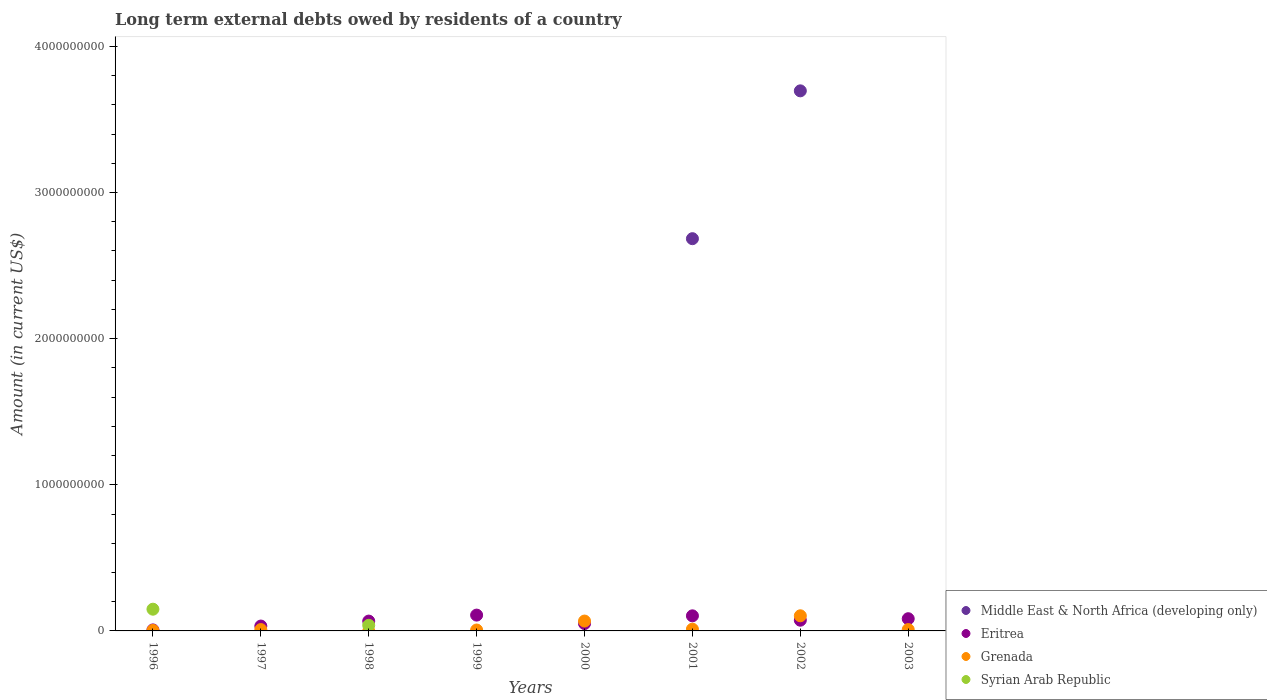Is the number of dotlines equal to the number of legend labels?
Ensure brevity in your answer.  No. What is the amount of long-term external debts owed by residents in Grenada in 1996?
Ensure brevity in your answer.  3.57e+06. Across all years, what is the maximum amount of long-term external debts owed by residents in Grenada?
Ensure brevity in your answer.  1.04e+08. Across all years, what is the minimum amount of long-term external debts owed by residents in Eritrea?
Make the answer very short. 6.93e+06. In which year was the amount of long-term external debts owed by residents in Syrian Arab Republic maximum?
Keep it short and to the point. 1996. What is the total amount of long-term external debts owed by residents in Grenada in the graph?
Your answer should be compact. 2.11e+08. What is the difference between the amount of long-term external debts owed by residents in Eritrea in 1996 and that in 1999?
Offer a terse response. -1.01e+08. What is the difference between the amount of long-term external debts owed by residents in Syrian Arab Republic in 2002 and the amount of long-term external debts owed by residents in Middle East & North Africa (developing only) in 2001?
Make the answer very short. -2.68e+09. What is the average amount of long-term external debts owed by residents in Eritrea per year?
Keep it short and to the point. 6.58e+07. In the year 2002, what is the difference between the amount of long-term external debts owed by residents in Eritrea and amount of long-term external debts owed by residents in Middle East & North Africa (developing only)?
Your answer should be compact. -3.62e+09. What is the ratio of the amount of long-term external debts owed by residents in Eritrea in 1999 to that in 2002?
Offer a very short reply. 1.48. Is the amount of long-term external debts owed by residents in Grenada in 1999 less than that in 2003?
Your response must be concise. Yes. What is the difference between the highest and the second highest amount of long-term external debts owed by residents in Eritrea?
Keep it short and to the point. 4.98e+06. What is the difference between the highest and the lowest amount of long-term external debts owed by residents in Grenada?
Your answer should be compact. 1.04e+08. Is it the case that in every year, the sum of the amount of long-term external debts owed by residents in Syrian Arab Republic and amount of long-term external debts owed by residents in Grenada  is greater than the sum of amount of long-term external debts owed by residents in Middle East & North Africa (developing only) and amount of long-term external debts owed by residents in Eritrea?
Offer a terse response. No. Is it the case that in every year, the sum of the amount of long-term external debts owed by residents in Eritrea and amount of long-term external debts owed by residents in Syrian Arab Republic  is greater than the amount of long-term external debts owed by residents in Grenada?
Make the answer very short. No. Is the amount of long-term external debts owed by residents in Middle East & North Africa (developing only) strictly less than the amount of long-term external debts owed by residents in Syrian Arab Republic over the years?
Provide a succinct answer. No. What is the difference between two consecutive major ticks on the Y-axis?
Ensure brevity in your answer.  1.00e+09. Are the values on the major ticks of Y-axis written in scientific E-notation?
Offer a terse response. No. Where does the legend appear in the graph?
Your answer should be compact. Bottom right. How many legend labels are there?
Offer a terse response. 4. What is the title of the graph?
Your answer should be compact. Long term external debts owed by residents of a country. Does "Switzerland" appear as one of the legend labels in the graph?
Your answer should be very brief. No. What is the label or title of the X-axis?
Give a very brief answer. Years. What is the label or title of the Y-axis?
Offer a very short reply. Amount (in current US$). What is the Amount (in current US$) of Eritrea in 1996?
Your answer should be very brief. 6.93e+06. What is the Amount (in current US$) of Grenada in 1996?
Keep it short and to the point. 3.57e+06. What is the Amount (in current US$) in Syrian Arab Republic in 1996?
Your response must be concise. 1.49e+08. What is the Amount (in current US$) in Eritrea in 1997?
Keep it short and to the point. 3.33e+07. What is the Amount (in current US$) of Grenada in 1997?
Your answer should be very brief. 9.23e+06. What is the Amount (in current US$) of Syrian Arab Republic in 1997?
Keep it short and to the point. 0. What is the Amount (in current US$) of Middle East & North Africa (developing only) in 1998?
Keep it short and to the point. 0. What is the Amount (in current US$) in Eritrea in 1998?
Offer a terse response. 6.73e+07. What is the Amount (in current US$) in Syrian Arab Republic in 1998?
Provide a short and direct response. 3.85e+07. What is the Amount (in current US$) in Middle East & North Africa (developing only) in 1999?
Ensure brevity in your answer.  0. What is the Amount (in current US$) in Eritrea in 1999?
Provide a short and direct response. 1.08e+08. What is the Amount (in current US$) of Grenada in 1999?
Offer a terse response. 6.29e+06. What is the Amount (in current US$) in Eritrea in 2000?
Provide a succinct answer. 5.02e+07. What is the Amount (in current US$) in Grenada in 2000?
Your response must be concise. 6.75e+07. What is the Amount (in current US$) of Syrian Arab Republic in 2000?
Offer a terse response. 0. What is the Amount (in current US$) in Middle East & North Africa (developing only) in 2001?
Offer a very short reply. 2.68e+09. What is the Amount (in current US$) of Eritrea in 2001?
Your answer should be very brief. 1.03e+08. What is the Amount (in current US$) in Grenada in 2001?
Offer a very short reply. 1.20e+07. What is the Amount (in current US$) of Syrian Arab Republic in 2001?
Make the answer very short. 0. What is the Amount (in current US$) of Middle East & North Africa (developing only) in 2002?
Keep it short and to the point. 3.70e+09. What is the Amount (in current US$) of Eritrea in 2002?
Make the answer very short. 7.33e+07. What is the Amount (in current US$) of Grenada in 2002?
Ensure brevity in your answer.  1.04e+08. What is the Amount (in current US$) of Syrian Arab Republic in 2002?
Offer a very short reply. 0. What is the Amount (in current US$) in Middle East & North Africa (developing only) in 2003?
Your answer should be compact. 0. What is the Amount (in current US$) in Eritrea in 2003?
Ensure brevity in your answer.  8.36e+07. What is the Amount (in current US$) of Grenada in 2003?
Offer a terse response. 9.30e+06. What is the Amount (in current US$) of Syrian Arab Republic in 2003?
Make the answer very short. 0. Across all years, what is the maximum Amount (in current US$) of Middle East & North Africa (developing only)?
Make the answer very short. 3.70e+09. Across all years, what is the maximum Amount (in current US$) of Eritrea?
Offer a terse response. 1.08e+08. Across all years, what is the maximum Amount (in current US$) of Grenada?
Your response must be concise. 1.04e+08. Across all years, what is the maximum Amount (in current US$) in Syrian Arab Republic?
Keep it short and to the point. 1.49e+08. Across all years, what is the minimum Amount (in current US$) in Eritrea?
Provide a succinct answer. 6.93e+06. Across all years, what is the minimum Amount (in current US$) in Grenada?
Provide a succinct answer. 0. Across all years, what is the minimum Amount (in current US$) of Syrian Arab Republic?
Your answer should be compact. 0. What is the total Amount (in current US$) of Middle East & North Africa (developing only) in the graph?
Give a very brief answer. 6.38e+09. What is the total Amount (in current US$) in Eritrea in the graph?
Keep it short and to the point. 5.26e+08. What is the total Amount (in current US$) of Grenada in the graph?
Your answer should be very brief. 2.11e+08. What is the total Amount (in current US$) of Syrian Arab Republic in the graph?
Provide a short and direct response. 1.87e+08. What is the difference between the Amount (in current US$) in Eritrea in 1996 and that in 1997?
Provide a short and direct response. -2.64e+07. What is the difference between the Amount (in current US$) in Grenada in 1996 and that in 1997?
Provide a succinct answer. -5.66e+06. What is the difference between the Amount (in current US$) of Eritrea in 1996 and that in 1998?
Give a very brief answer. -6.03e+07. What is the difference between the Amount (in current US$) in Syrian Arab Republic in 1996 and that in 1998?
Provide a succinct answer. 1.10e+08. What is the difference between the Amount (in current US$) in Eritrea in 1996 and that in 1999?
Keep it short and to the point. -1.01e+08. What is the difference between the Amount (in current US$) in Grenada in 1996 and that in 1999?
Keep it short and to the point. -2.72e+06. What is the difference between the Amount (in current US$) in Eritrea in 1996 and that in 2000?
Ensure brevity in your answer.  -4.33e+07. What is the difference between the Amount (in current US$) of Grenada in 1996 and that in 2000?
Your response must be concise. -6.39e+07. What is the difference between the Amount (in current US$) of Eritrea in 1996 and that in 2001?
Your answer should be compact. -9.63e+07. What is the difference between the Amount (in current US$) in Grenada in 1996 and that in 2001?
Provide a succinct answer. -8.42e+06. What is the difference between the Amount (in current US$) of Eritrea in 1996 and that in 2002?
Your answer should be compact. -6.64e+07. What is the difference between the Amount (in current US$) in Grenada in 1996 and that in 2002?
Your response must be concise. -1.00e+08. What is the difference between the Amount (in current US$) in Eritrea in 1996 and that in 2003?
Keep it short and to the point. -7.67e+07. What is the difference between the Amount (in current US$) in Grenada in 1996 and that in 2003?
Ensure brevity in your answer.  -5.73e+06. What is the difference between the Amount (in current US$) of Eritrea in 1997 and that in 1998?
Your answer should be very brief. -3.40e+07. What is the difference between the Amount (in current US$) of Eritrea in 1997 and that in 1999?
Make the answer very short. -7.49e+07. What is the difference between the Amount (in current US$) of Grenada in 1997 and that in 1999?
Your response must be concise. 2.94e+06. What is the difference between the Amount (in current US$) in Eritrea in 1997 and that in 2000?
Your answer should be very brief. -1.69e+07. What is the difference between the Amount (in current US$) in Grenada in 1997 and that in 2000?
Keep it short and to the point. -5.83e+07. What is the difference between the Amount (in current US$) in Eritrea in 1997 and that in 2001?
Provide a succinct answer. -6.99e+07. What is the difference between the Amount (in current US$) of Grenada in 1997 and that in 2001?
Provide a short and direct response. -2.77e+06. What is the difference between the Amount (in current US$) in Eritrea in 1997 and that in 2002?
Your response must be concise. -4.00e+07. What is the difference between the Amount (in current US$) of Grenada in 1997 and that in 2002?
Your response must be concise. -9.43e+07. What is the difference between the Amount (in current US$) in Eritrea in 1997 and that in 2003?
Offer a terse response. -5.03e+07. What is the difference between the Amount (in current US$) of Grenada in 1997 and that in 2003?
Ensure brevity in your answer.  -7.40e+04. What is the difference between the Amount (in current US$) in Eritrea in 1998 and that in 1999?
Keep it short and to the point. -4.10e+07. What is the difference between the Amount (in current US$) of Eritrea in 1998 and that in 2000?
Ensure brevity in your answer.  1.70e+07. What is the difference between the Amount (in current US$) of Eritrea in 1998 and that in 2001?
Your answer should be very brief. -3.60e+07. What is the difference between the Amount (in current US$) in Eritrea in 1998 and that in 2002?
Offer a terse response. -6.06e+06. What is the difference between the Amount (in current US$) in Eritrea in 1998 and that in 2003?
Offer a very short reply. -1.63e+07. What is the difference between the Amount (in current US$) in Eritrea in 1999 and that in 2000?
Your response must be concise. 5.80e+07. What is the difference between the Amount (in current US$) in Grenada in 1999 and that in 2000?
Offer a terse response. -6.12e+07. What is the difference between the Amount (in current US$) in Eritrea in 1999 and that in 2001?
Provide a succinct answer. 4.98e+06. What is the difference between the Amount (in current US$) in Grenada in 1999 and that in 2001?
Give a very brief answer. -5.71e+06. What is the difference between the Amount (in current US$) of Eritrea in 1999 and that in 2002?
Offer a terse response. 3.49e+07. What is the difference between the Amount (in current US$) of Grenada in 1999 and that in 2002?
Your answer should be very brief. -9.72e+07. What is the difference between the Amount (in current US$) of Eritrea in 1999 and that in 2003?
Give a very brief answer. 2.47e+07. What is the difference between the Amount (in current US$) of Grenada in 1999 and that in 2003?
Your answer should be very brief. -3.01e+06. What is the difference between the Amount (in current US$) of Eritrea in 2000 and that in 2001?
Your answer should be very brief. -5.30e+07. What is the difference between the Amount (in current US$) in Grenada in 2000 and that in 2001?
Your answer should be very brief. 5.55e+07. What is the difference between the Amount (in current US$) in Eritrea in 2000 and that in 2002?
Provide a succinct answer. -2.31e+07. What is the difference between the Amount (in current US$) of Grenada in 2000 and that in 2002?
Your answer should be very brief. -3.60e+07. What is the difference between the Amount (in current US$) in Eritrea in 2000 and that in 2003?
Offer a terse response. -3.33e+07. What is the difference between the Amount (in current US$) of Grenada in 2000 and that in 2003?
Your answer should be compact. 5.82e+07. What is the difference between the Amount (in current US$) in Middle East & North Africa (developing only) in 2001 and that in 2002?
Offer a terse response. -1.01e+09. What is the difference between the Amount (in current US$) of Eritrea in 2001 and that in 2002?
Make the answer very short. 2.99e+07. What is the difference between the Amount (in current US$) of Grenada in 2001 and that in 2002?
Make the answer very short. -9.15e+07. What is the difference between the Amount (in current US$) in Eritrea in 2001 and that in 2003?
Your answer should be compact. 1.97e+07. What is the difference between the Amount (in current US$) of Grenada in 2001 and that in 2003?
Keep it short and to the point. 2.70e+06. What is the difference between the Amount (in current US$) of Eritrea in 2002 and that in 2003?
Give a very brief answer. -1.02e+07. What is the difference between the Amount (in current US$) in Grenada in 2002 and that in 2003?
Your answer should be compact. 9.42e+07. What is the difference between the Amount (in current US$) in Eritrea in 1996 and the Amount (in current US$) in Grenada in 1997?
Ensure brevity in your answer.  -2.30e+06. What is the difference between the Amount (in current US$) in Eritrea in 1996 and the Amount (in current US$) in Syrian Arab Republic in 1998?
Keep it short and to the point. -3.16e+07. What is the difference between the Amount (in current US$) in Grenada in 1996 and the Amount (in current US$) in Syrian Arab Republic in 1998?
Make the answer very short. -3.49e+07. What is the difference between the Amount (in current US$) of Eritrea in 1996 and the Amount (in current US$) of Grenada in 1999?
Your answer should be compact. 6.42e+05. What is the difference between the Amount (in current US$) of Eritrea in 1996 and the Amount (in current US$) of Grenada in 2000?
Your answer should be very brief. -6.06e+07. What is the difference between the Amount (in current US$) in Eritrea in 1996 and the Amount (in current US$) in Grenada in 2001?
Your answer should be very brief. -5.06e+06. What is the difference between the Amount (in current US$) in Eritrea in 1996 and the Amount (in current US$) in Grenada in 2002?
Provide a short and direct response. -9.66e+07. What is the difference between the Amount (in current US$) of Eritrea in 1996 and the Amount (in current US$) of Grenada in 2003?
Your answer should be very brief. -2.37e+06. What is the difference between the Amount (in current US$) in Eritrea in 1997 and the Amount (in current US$) in Syrian Arab Republic in 1998?
Make the answer very short. -5.19e+06. What is the difference between the Amount (in current US$) in Grenada in 1997 and the Amount (in current US$) in Syrian Arab Republic in 1998?
Offer a terse response. -2.93e+07. What is the difference between the Amount (in current US$) of Eritrea in 1997 and the Amount (in current US$) of Grenada in 1999?
Your response must be concise. 2.70e+07. What is the difference between the Amount (in current US$) of Eritrea in 1997 and the Amount (in current US$) of Grenada in 2000?
Give a very brief answer. -3.42e+07. What is the difference between the Amount (in current US$) in Eritrea in 1997 and the Amount (in current US$) in Grenada in 2001?
Make the answer very short. 2.13e+07. What is the difference between the Amount (in current US$) of Eritrea in 1997 and the Amount (in current US$) of Grenada in 2002?
Offer a terse response. -7.02e+07. What is the difference between the Amount (in current US$) in Eritrea in 1997 and the Amount (in current US$) in Grenada in 2003?
Your answer should be very brief. 2.40e+07. What is the difference between the Amount (in current US$) of Eritrea in 1998 and the Amount (in current US$) of Grenada in 1999?
Offer a very short reply. 6.10e+07. What is the difference between the Amount (in current US$) in Eritrea in 1998 and the Amount (in current US$) in Grenada in 2000?
Offer a very short reply. -2.25e+05. What is the difference between the Amount (in current US$) of Eritrea in 1998 and the Amount (in current US$) of Grenada in 2001?
Your answer should be compact. 5.53e+07. What is the difference between the Amount (in current US$) in Eritrea in 1998 and the Amount (in current US$) in Grenada in 2002?
Your answer should be compact. -3.62e+07. What is the difference between the Amount (in current US$) in Eritrea in 1998 and the Amount (in current US$) in Grenada in 2003?
Your answer should be compact. 5.80e+07. What is the difference between the Amount (in current US$) in Eritrea in 1999 and the Amount (in current US$) in Grenada in 2000?
Provide a succinct answer. 4.07e+07. What is the difference between the Amount (in current US$) in Eritrea in 1999 and the Amount (in current US$) in Grenada in 2001?
Keep it short and to the point. 9.62e+07. What is the difference between the Amount (in current US$) of Eritrea in 1999 and the Amount (in current US$) of Grenada in 2002?
Keep it short and to the point. 4.71e+06. What is the difference between the Amount (in current US$) in Eritrea in 1999 and the Amount (in current US$) in Grenada in 2003?
Make the answer very short. 9.89e+07. What is the difference between the Amount (in current US$) in Eritrea in 2000 and the Amount (in current US$) in Grenada in 2001?
Provide a succinct answer. 3.83e+07. What is the difference between the Amount (in current US$) of Eritrea in 2000 and the Amount (in current US$) of Grenada in 2002?
Offer a terse response. -5.33e+07. What is the difference between the Amount (in current US$) of Eritrea in 2000 and the Amount (in current US$) of Grenada in 2003?
Ensure brevity in your answer.  4.09e+07. What is the difference between the Amount (in current US$) of Middle East & North Africa (developing only) in 2001 and the Amount (in current US$) of Eritrea in 2002?
Your answer should be compact. 2.61e+09. What is the difference between the Amount (in current US$) in Middle East & North Africa (developing only) in 2001 and the Amount (in current US$) in Grenada in 2002?
Keep it short and to the point. 2.58e+09. What is the difference between the Amount (in current US$) in Eritrea in 2001 and the Amount (in current US$) in Grenada in 2002?
Ensure brevity in your answer.  -2.67e+05. What is the difference between the Amount (in current US$) in Middle East & North Africa (developing only) in 2001 and the Amount (in current US$) in Eritrea in 2003?
Provide a short and direct response. 2.60e+09. What is the difference between the Amount (in current US$) of Middle East & North Africa (developing only) in 2001 and the Amount (in current US$) of Grenada in 2003?
Your answer should be very brief. 2.67e+09. What is the difference between the Amount (in current US$) of Eritrea in 2001 and the Amount (in current US$) of Grenada in 2003?
Keep it short and to the point. 9.40e+07. What is the difference between the Amount (in current US$) in Middle East & North Africa (developing only) in 2002 and the Amount (in current US$) in Eritrea in 2003?
Make the answer very short. 3.61e+09. What is the difference between the Amount (in current US$) of Middle East & North Africa (developing only) in 2002 and the Amount (in current US$) of Grenada in 2003?
Provide a succinct answer. 3.69e+09. What is the difference between the Amount (in current US$) of Eritrea in 2002 and the Amount (in current US$) of Grenada in 2003?
Your answer should be very brief. 6.40e+07. What is the average Amount (in current US$) of Middle East & North Africa (developing only) per year?
Your answer should be very brief. 7.97e+08. What is the average Amount (in current US$) of Eritrea per year?
Make the answer very short. 6.58e+07. What is the average Amount (in current US$) in Grenada per year?
Offer a terse response. 2.64e+07. What is the average Amount (in current US$) in Syrian Arab Republic per year?
Offer a very short reply. 2.34e+07. In the year 1996, what is the difference between the Amount (in current US$) in Eritrea and Amount (in current US$) in Grenada?
Provide a short and direct response. 3.36e+06. In the year 1996, what is the difference between the Amount (in current US$) of Eritrea and Amount (in current US$) of Syrian Arab Republic?
Offer a terse response. -1.42e+08. In the year 1996, what is the difference between the Amount (in current US$) in Grenada and Amount (in current US$) in Syrian Arab Republic?
Provide a short and direct response. -1.45e+08. In the year 1997, what is the difference between the Amount (in current US$) in Eritrea and Amount (in current US$) in Grenada?
Ensure brevity in your answer.  2.41e+07. In the year 1998, what is the difference between the Amount (in current US$) of Eritrea and Amount (in current US$) of Syrian Arab Republic?
Keep it short and to the point. 2.88e+07. In the year 1999, what is the difference between the Amount (in current US$) in Eritrea and Amount (in current US$) in Grenada?
Offer a terse response. 1.02e+08. In the year 2000, what is the difference between the Amount (in current US$) of Eritrea and Amount (in current US$) of Grenada?
Offer a very short reply. -1.73e+07. In the year 2001, what is the difference between the Amount (in current US$) of Middle East & North Africa (developing only) and Amount (in current US$) of Eritrea?
Offer a very short reply. 2.58e+09. In the year 2001, what is the difference between the Amount (in current US$) in Middle East & North Africa (developing only) and Amount (in current US$) in Grenada?
Your answer should be compact. 2.67e+09. In the year 2001, what is the difference between the Amount (in current US$) of Eritrea and Amount (in current US$) of Grenada?
Provide a short and direct response. 9.13e+07. In the year 2002, what is the difference between the Amount (in current US$) in Middle East & North Africa (developing only) and Amount (in current US$) in Eritrea?
Ensure brevity in your answer.  3.62e+09. In the year 2002, what is the difference between the Amount (in current US$) in Middle East & North Africa (developing only) and Amount (in current US$) in Grenada?
Your answer should be compact. 3.59e+09. In the year 2002, what is the difference between the Amount (in current US$) in Eritrea and Amount (in current US$) in Grenada?
Make the answer very short. -3.02e+07. In the year 2003, what is the difference between the Amount (in current US$) in Eritrea and Amount (in current US$) in Grenada?
Offer a very short reply. 7.43e+07. What is the ratio of the Amount (in current US$) of Eritrea in 1996 to that in 1997?
Your response must be concise. 0.21. What is the ratio of the Amount (in current US$) of Grenada in 1996 to that in 1997?
Offer a terse response. 0.39. What is the ratio of the Amount (in current US$) in Eritrea in 1996 to that in 1998?
Offer a terse response. 0.1. What is the ratio of the Amount (in current US$) of Syrian Arab Republic in 1996 to that in 1998?
Keep it short and to the point. 3.86. What is the ratio of the Amount (in current US$) in Eritrea in 1996 to that in 1999?
Your response must be concise. 0.06. What is the ratio of the Amount (in current US$) in Grenada in 1996 to that in 1999?
Offer a very short reply. 0.57. What is the ratio of the Amount (in current US$) in Eritrea in 1996 to that in 2000?
Make the answer very short. 0.14. What is the ratio of the Amount (in current US$) of Grenada in 1996 to that in 2000?
Give a very brief answer. 0.05. What is the ratio of the Amount (in current US$) of Eritrea in 1996 to that in 2001?
Offer a very short reply. 0.07. What is the ratio of the Amount (in current US$) of Grenada in 1996 to that in 2001?
Keep it short and to the point. 0.3. What is the ratio of the Amount (in current US$) in Eritrea in 1996 to that in 2002?
Provide a short and direct response. 0.09. What is the ratio of the Amount (in current US$) in Grenada in 1996 to that in 2002?
Your answer should be compact. 0.03. What is the ratio of the Amount (in current US$) of Eritrea in 1996 to that in 2003?
Offer a terse response. 0.08. What is the ratio of the Amount (in current US$) of Grenada in 1996 to that in 2003?
Keep it short and to the point. 0.38. What is the ratio of the Amount (in current US$) of Eritrea in 1997 to that in 1998?
Give a very brief answer. 0.5. What is the ratio of the Amount (in current US$) in Eritrea in 1997 to that in 1999?
Give a very brief answer. 0.31. What is the ratio of the Amount (in current US$) of Grenada in 1997 to that in 1999?
Make the answer very short. 1.47. What is the ratio of the Amount (in current US$) in Eritrea in 1997 to that in 2000?
Provide a short and direct response. 0.66. What is the ratio of the Amount (in current US$) in Grenada in 1997 to that in 2000?
Your answer should be compact. 0.14. What is the ratio of the Amount (in current US$) of Eritrea in 1997 to that in 2001?
Your answer should be very brief. 0.32. What is the ratio of the Amount (in current US$) in Grenada in 1997 to that in 2001?
Your response must be concise. 0.77. What is the ratio of the Amount (in current US$) in Eritrea in 1997 to that in 2002?
Your response must be concise. 0.45. What is the ratio of the Amount (in current US$) of Grenada in 1997 to that in 2002?
Provide a succinct answer. 0.09. What is the ratio of the Amount (in current US$) in Eritrea in 1997 to that in 2003?
Offer a terse response. 0.4. What is the ratio of the Amount (in current US$) in Eritrea in 1998 to that in 1999?
Offer a terse response. 0.62. What is the ratio of the Amount (in current US$) in Eritrea in 1998 to that in 2000?
Ensure brevity in your answer.  1.34. What is the ratio of the Amount (in current US$) in Eritrea in 1998 to that in 2001?
Keep it short and to the point. 0.65. What is the ratio of the Amount (in current US$) in Eritrea in 1998 to that in 2002?
Give a very brief answer. 0.92. What is the ratio of the Amount (in current US$) of Eritrea in 1998 to that in 2003?
Offer a very short reply. 0.8. What is the ratio of the Amount (in current US$) in Eritrea in 1999 to that in 2000?
Ensure brevity in your answer.  2.15. What is the ratio of the Amount (in current US$) of Grenada in 1999 to that in 2000?
Your answer should be very brief. 0.09. What is the ratio of the Amount (in current US$) of Eritrea in 1999 to that in 2001?
Ensure brevity in your answer.  1.05. What is the ratio of the Amount (in current US$) of Grenada in 1999 to that in 2001?
Provide a succinct answer. 0.52. What is the ratio of the Amount (in current US$) of Eritrea in 1999 to that in 2002?
Ensure brevity in your answer.  1.48. What is the ratio of the Amount (in current US$) in Grenada in 1999 to that in 2002?
Your answer should be very brief. 0.06. What is the ratio of the Amount (in current US$) of Eritrea in 1999 to that in 2003?
Make the answer very short. 1.29. What is the ratio of the Amount (in current US$) in Grenada in 1999 to that in 2003?
Give a very brief answer. 0.68. What is the ratio of the Amount (in current US$) in Eritrea in 2000 to that in 2001?
Make the answer very short. 0.49. What is the ratio of the Amount (in current US$) of Grenada in 2000 to that in 2001?
Provide a short and direct response. 5.63. What is the ratio of the Amount (in current US$) in Eritrea in 2000 to that in 2002?
Give a very brief answer. 0.69. What is the ratio of the Amount (in current US$) in Grenada in 2000 to that in 2002?
Your answer should be very brief. 0.65. What is the ratio of the Amount (in current US$) in Eritrea in 2000 to that in 2003?
Keep it short and to the point. 0.6. What is the ratio of the Amount (in current US$) of Grenada in 2000 to that in 2003?
Ensure brevity in your answer.  7.26. What is the ratio of the Amount (in current US$) of Middle East & North Africa (developing only) in 2001 to that in 2002?
Provide a short and direct response. 0.73. What is the ratio of the Amount (in current US$) in Eritrea in 2001 to that in 2002?
Your response must be concise. 1.41. What is the ratio of the Amount (in current US$) of Grenada in 2001 to that in 2002?
Offer a very short reply. 0.12. What is the ratio of the Amount (in current US$) in Eritrea in 2001 to that in 2003?
Keep it short and to the point. 1.24. What is the ratio of the Amount (in current US$) of Grenada in 2001 to that in 2003?
Provide a succinct answer. 1.29. What is the ratio of the Amount (in current US$) of Eritrea in 2002 to that in 2003?
Give a very brief answer. 0.88. What is the ratio of the Amount (in current US$) in Grenada in 2002 to that in 2003?
Give a very brief answer. 11.13. What is the difference between the highest and the second highest Amount (in current US$) of Eritrea?
Provide a short and direct response. 4.98e+06. What is the difference between the highest and the second highest Amount (in current US$) in Grenada?
Your response must be concise. 3.60e+07. What is the difference between the highest and the lowest Amount (in current US$) in Middle East & North Africa (developing only)?
Keep it short and to the point. 3.70e+09. What is the difference between the highest and the lowest Amount (in current US$) of Eritrea?
Keep it short and to the point. 1.01e+08. What is the difference between the highest and the lowest Amount (in current US$) of Grenada?
Provide a succinct answer. 1.04e+08. What is the difference between the highest and the lowest Amount (in current US$) of Syrian Arab Republic?
Ensure brevity in your answer.  1.49e+08. 